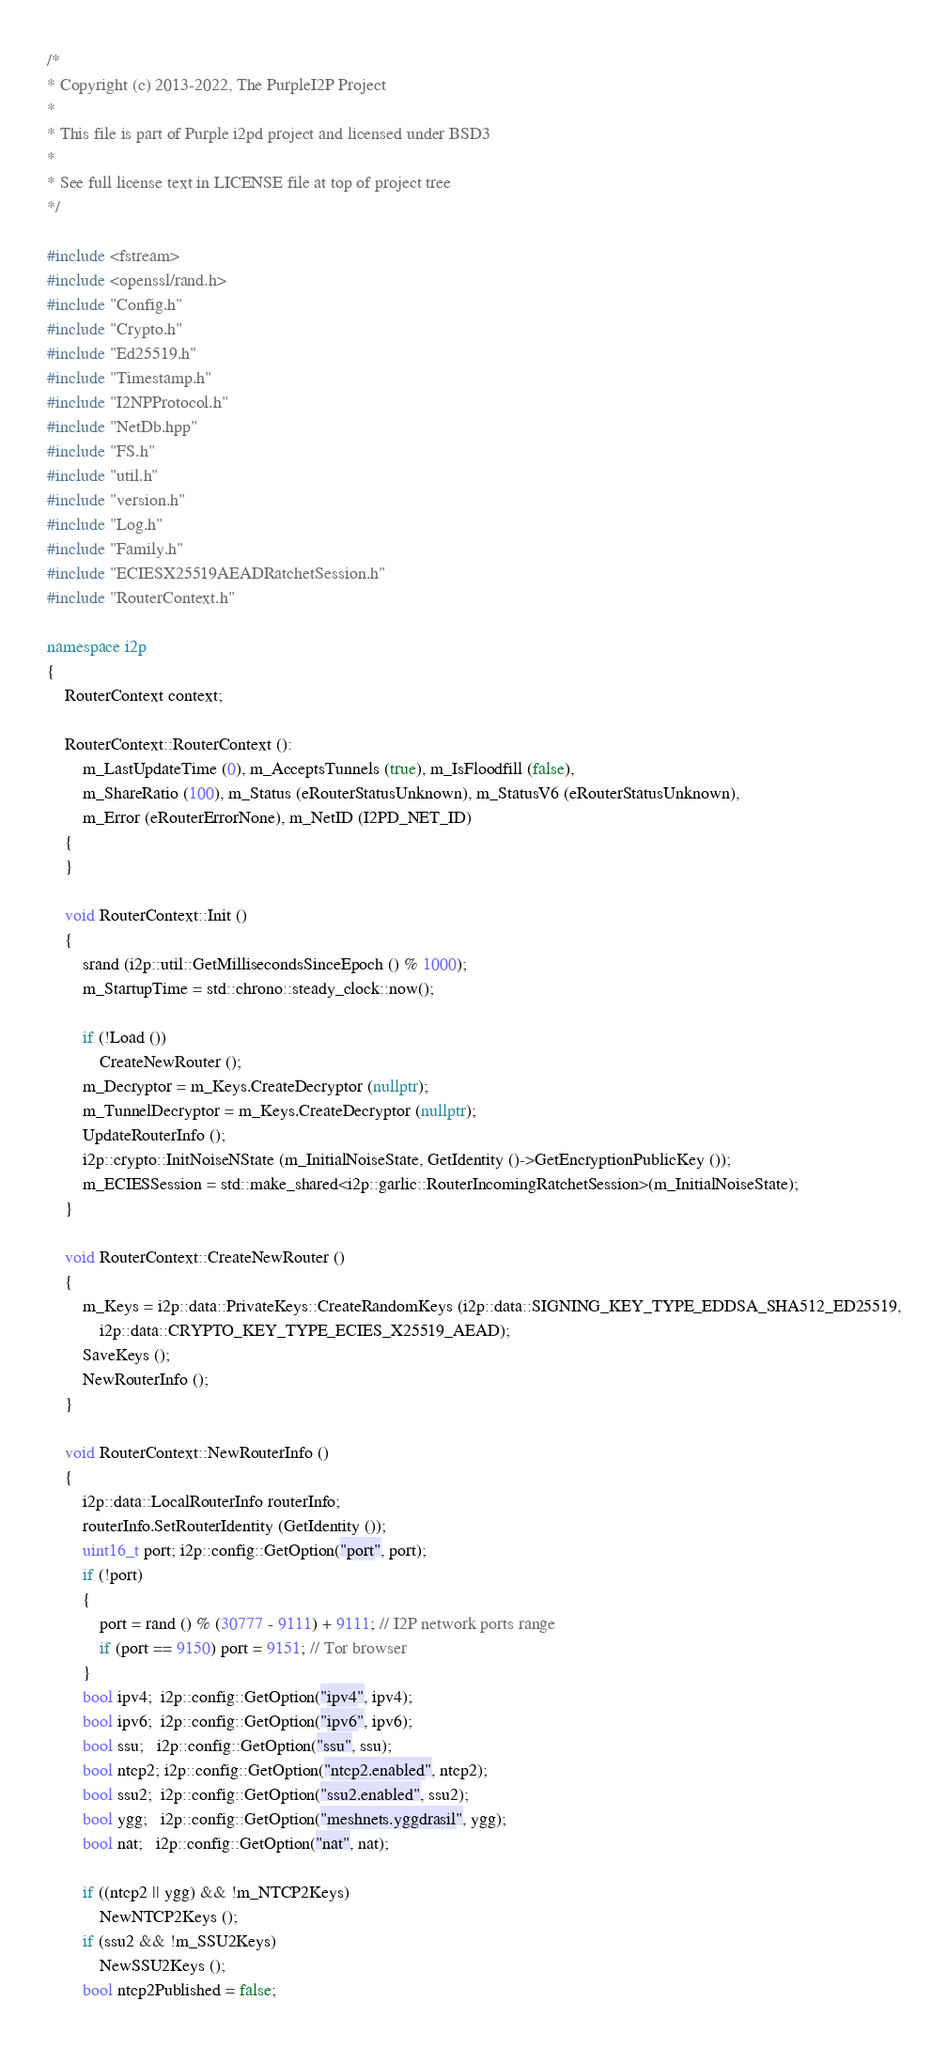Convert code to text. <code><loc_0><loc_0><loc_500><loc_500><_C++_>/*
* Copyright (c) 2013-2022, The PurpleI2P Project
*
* This file is part of Purple i2pd project and licensed under BSD3
*
* See full license text in LICENSE file at top of project tree
*/

#include <fstream>
#include <openssl/rand.h>
#include "Config.h"
#include "Crypto.h"
#include "Ed25519.h"
#include "Timestamp.h"
#include "I2NPProtocol.h"
#include "NetDb.hpp"
#include "FS.h"
#include "util.h"
#include "version.h"
#include "Log.h"
#include "Family.h"
#include "ECIESX25519AEADRatchetSession.h"
#include "RouterContext.h"

namespace i2p
{
	RouterContext context;

	RouterContext::RouterContext ():
		m_LastUpdateTime (0), m_AcceptsTunnels (true), m_IsFloodfill (false),
		m_ShareRatio (100), m_Status (eRouterStatusUnknown), m_StatusV6 (eRouterStatusUnknown),
		m_Error (eRouterErrorNone), m_NetID (I2PD_NET_ID)
	{
	}

	void RouterContext::Init ()
	{
		srand (i2p::util::GetMillisecondsSinceEpoch () % 1000);
		m_StartupTime = std::chrono::steady_clock::now();

		if (!Load ())
			CreateNewRouter ();
		m_Decryptor = m_Keys.CreateDecryptor (nullptr);
		m_TunnelDecryptor = m_Keys.CreateDecryptor (nullptr);
		UpdateRouterInfo ();
		i2p::crypto::InitNoiseNState (m_InitialNoiseState, GetIdentity ()->GetEncryptionPublicKey ());
		m_ECIESSession = std::make_shared<i2p::garlic::RouterIncomingRatchetSession>(m_InitialNoiseState);
	}

	void RouterContext::CreateNewRouter ()
	{
		m_Keys = i2p::data::PrivateKeys::CreateRandomKeys (i2p::data::SIGNING_KEY_TYPE_EDDSA_SHA512_ED25519,
			i2p::data::CRYPTO_KEY_TYPE_ECIES_X25519_AEAD);
		SaveKeys ();
		NewRouterInfo ();
	}

	void RouterContext::NewRouterInfo ()
	{
		i2p::data::LocalRouterInfo routerInfo;
		routerInfo.SetRouterIdentity (GetIdentity ());
		uint16_t port; i2p::config::GetOption("port", port);
		if (!port)
		{
			port = rand () % (30777 - 9111) + 9111; // I2P network ports range
			if (port == 9150) port = 9151; // Tor browser
		}
		bool ipv4;  i2p::config::GetOption("ipv4", ipv4);
		bool ipv6;  i2p::config::GetOption("ipv6", ipv6);
		bool ssu;   i2p::config::GetOption("ssu", ssu);
		bool ntcp2; i2p::config::GetOption("ntcp2.enabled", ntcp2);
		bool ssu2;  i2p::config::GetOption("ssu2.enabled", ssu2);
		bool ygg;   i2p::config::GetOption("meshnets.yggdrasil", ygg);
		bool nat;   i2p::config::GetOption("nat", nat);

		if ((ntcp2 || ygg) && !m_NTCP2Keys)
			NewNTCP2Keys ();
		if (ssu2 && !m_SSU2Keys)
			NewSSU2Keys ();
		bool ntcp2Published = false;</code> 